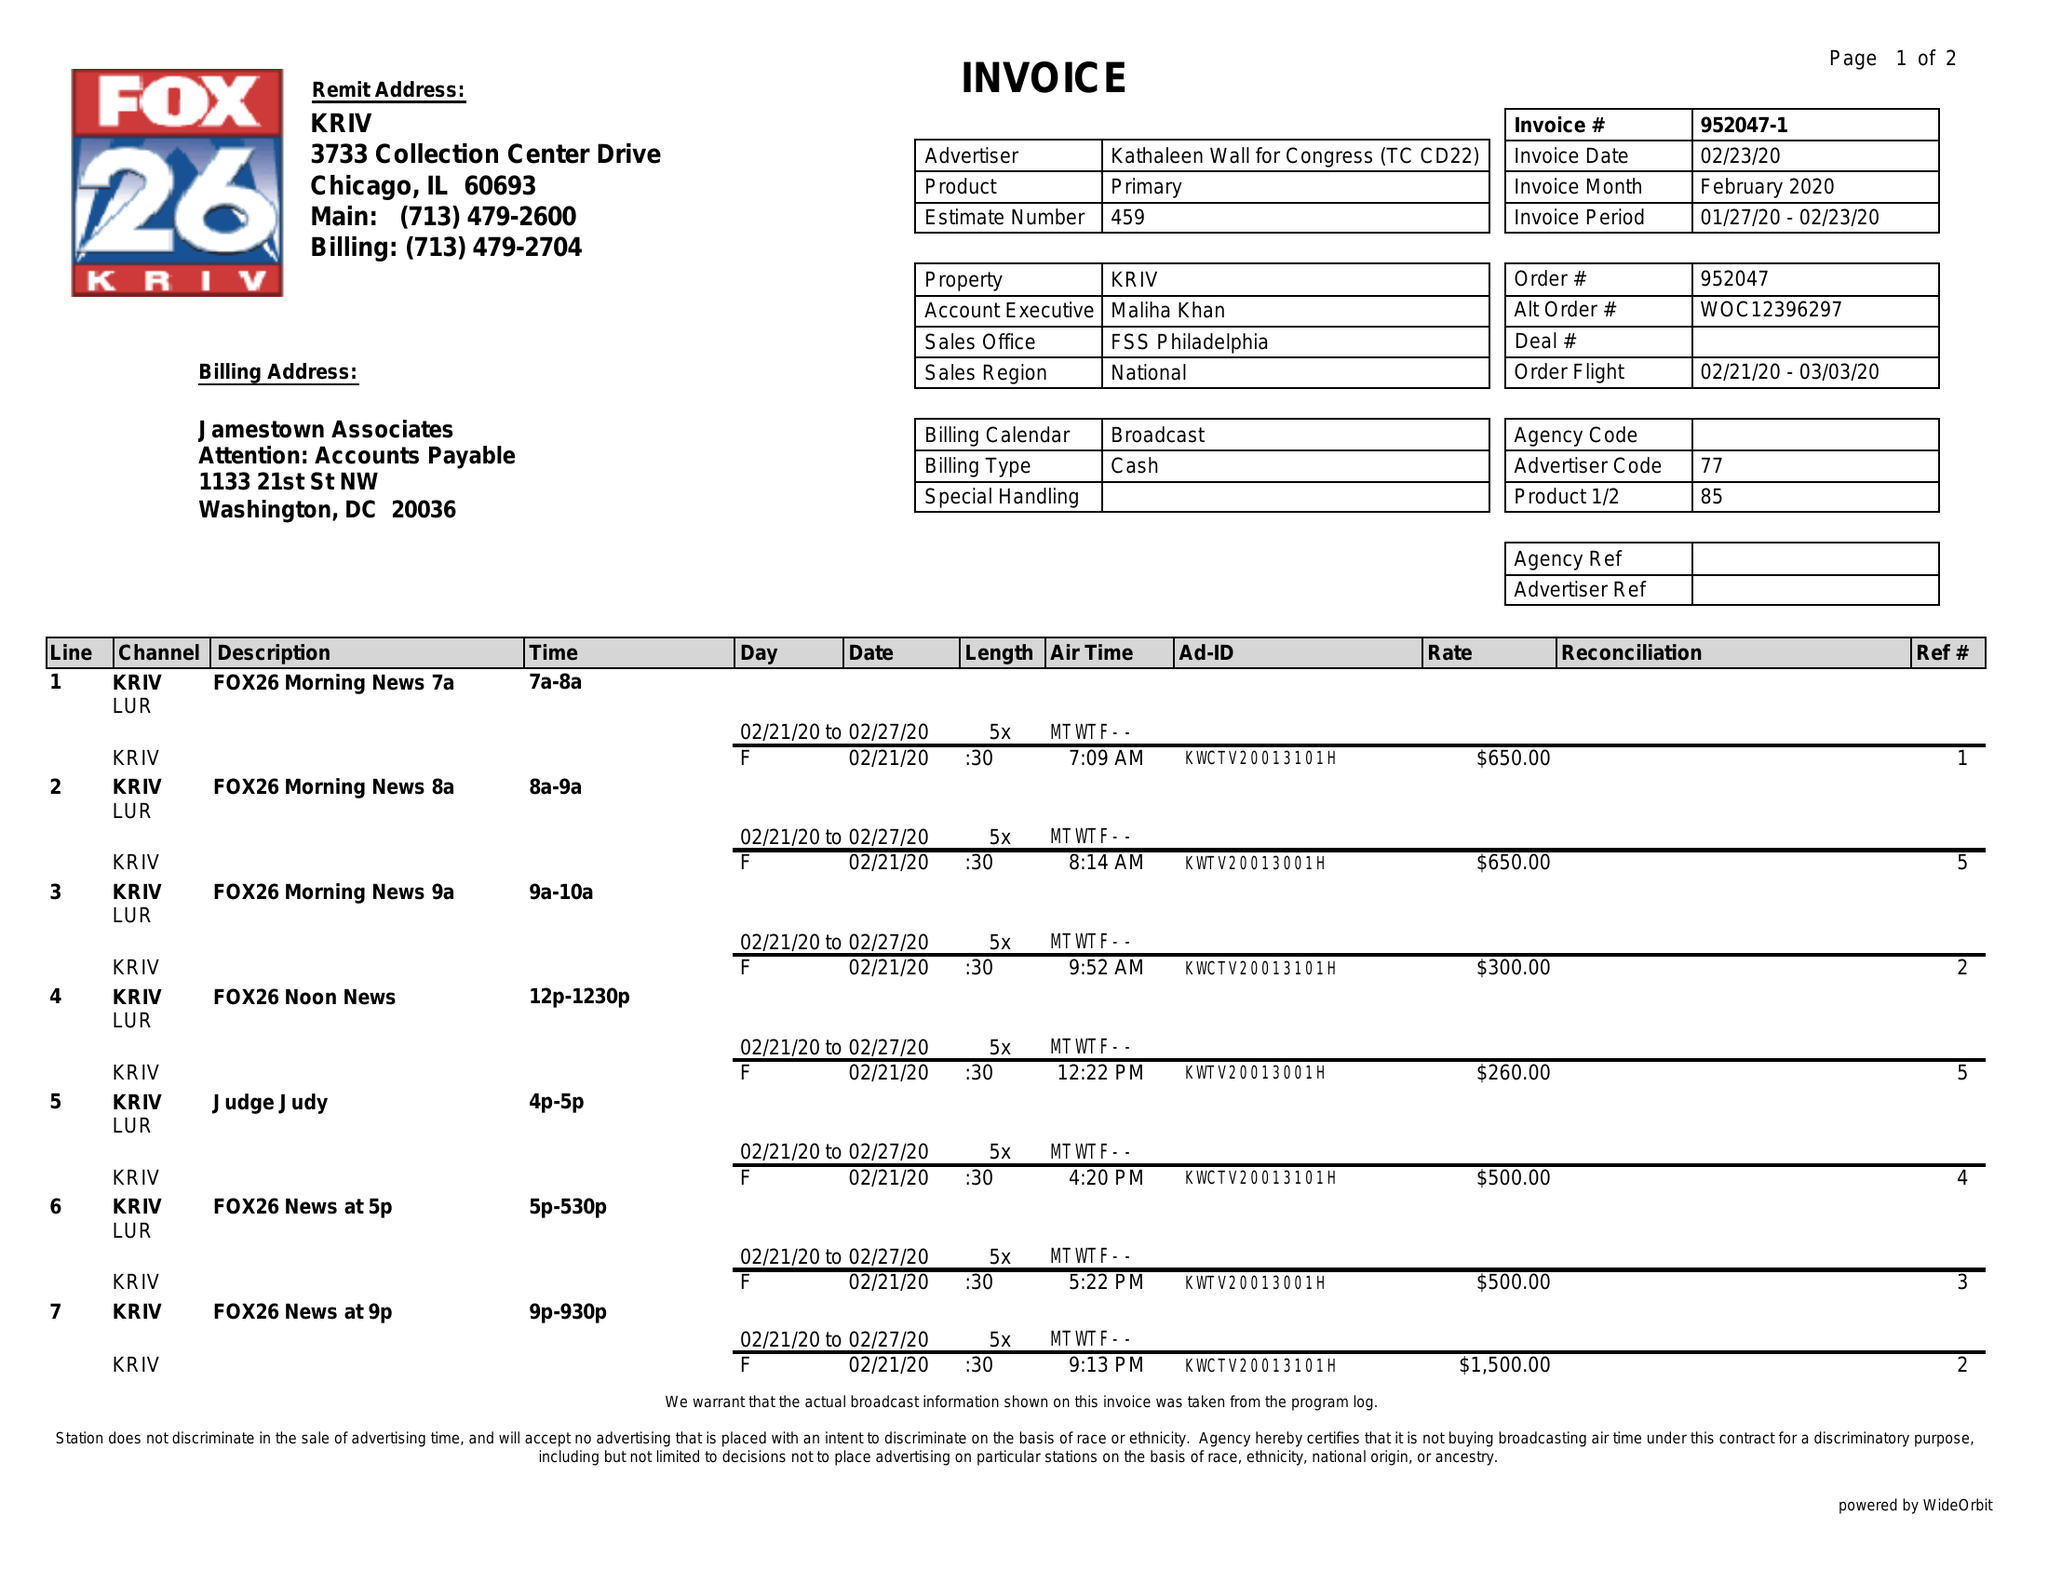What is the value for the contract_num?
Answer the question using a single word or phrase. 952047 